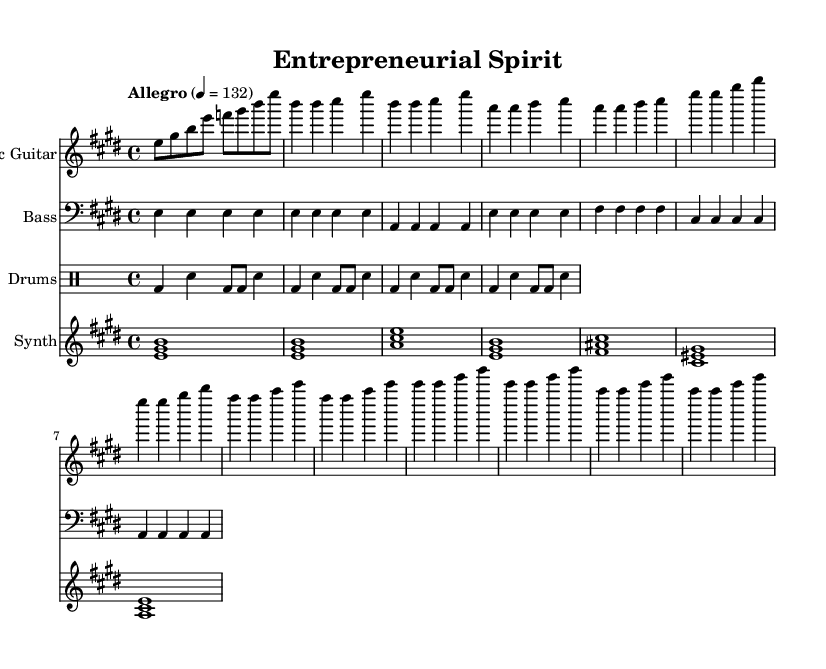What key signature is used in this music? The key signature is E major, which has four sharps: F#, C#, G#, and D#.
Answer: E major What is the time signature of this piece? The time signature is 4/4, meaning there are four beats in a measure and a quarter note receives one beat.
Answer: 4/4 What is the tempo marking for this piece? The tempo marking is Allegro, which indicates a fast and lively speed of 132 beats per minute.
Answer: Allegro How many measures are in the verse section? The verse section consists of four measures as indicated by the grouping of notes played.
Answer: 4 What is the primary instrument featured in the intro? The primary instrument featured in the intro is the electric guitar, which plays the melody.
Answer: Electric guitar What type of chord is sustained in the synth pad? The synth pad plays sustained chords with the notes E, G#, and B, indicating an E major chord.
Answer: E major chord How is the drum rhythm structured in this piece? The drum rhythm follows a basic rock beat pattern, consisting of bass drums and snare played in a steady 4/4 time.
Answer: Basic rock beat 